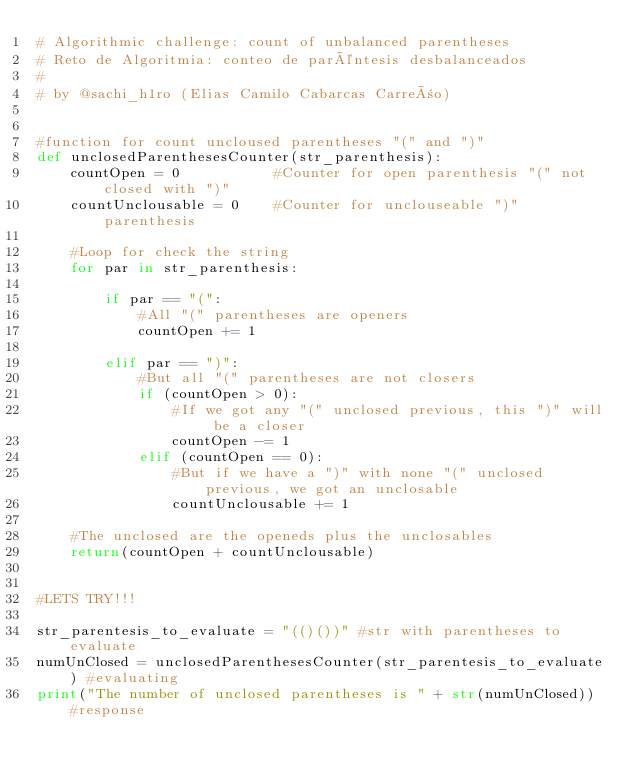Convert code to text. <code><loc_0><loc_0><loc_500><loc_500><_Python_># Algorithmic challenge: count of unbalanced parentheses
# Reto de Algoritmia: conteo de paréntesis desbalanceados
#
# by @sachi_h1ro (Elias Camilo Cabarcas Carreño)


#function for count uncloused parentheses "(" and ")"
def unclosedParenthesesCounter(str_parenthesis):
    countOpen = 0           #Counter for open parenthesis "(" not closed with ")"
    countUnclousable = 0    #Counter for unclouseable ")" parenthesis

    #Loop for check the string
    for par in str_parenthesis:
        
        if par == "(":
            #All "(" parentheses are openers
            countOpen += 1

        elif par == ")":
            #But all "(" parentheses are not closers
            if (countOpen > 0):
                #If we got any "(" unclosed previous, this ")" will be a closer
                countOpen -= 1
            elif (countOpen == 0):
                #But if we have a ")" with none "(" unclosed previous, we got an unclosable
                countUnclousable += 1
    
    #The unclosed are the openeds plus the unclosables
    return(countOpen + countUnclousable)


#LETS TRY!!!

str_parentesis_to_evaluate = "(()())" #str with parentheses to evaluate
numUnClosed = unclosedParenthesesCounter(str_parentesis_to_evaluate) #evaluating
print("The number of unclosed parentheses is " + str(numUnClosed)) #response
</code> 